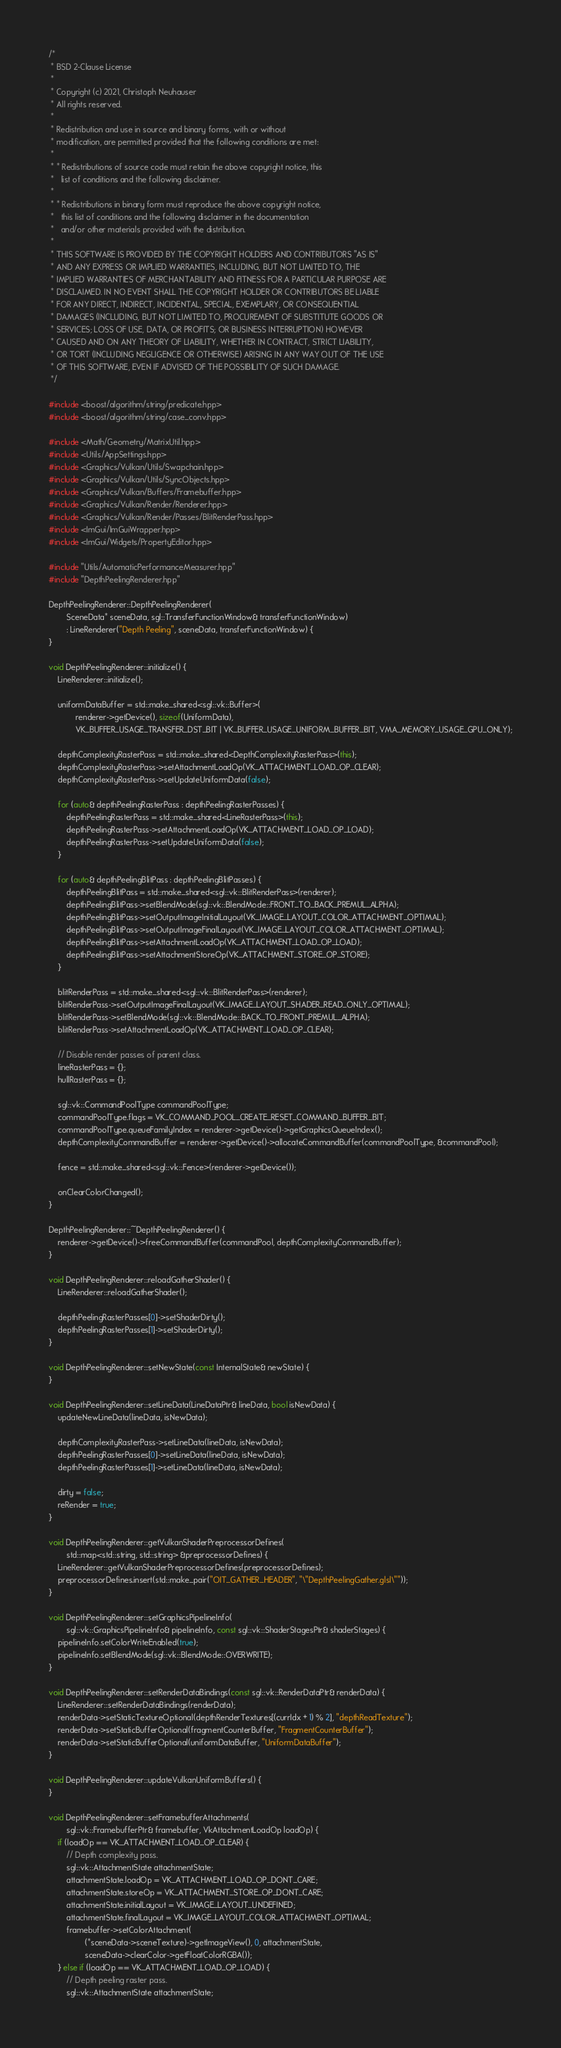<code> <loc_0><loc_0><loc_500><loc_500><_C++_>/*
 * BSD 2-Clause License
 *
 * Copyright (c) 2021, Christoph Neuhauser
 * All rights reserved.
 *
 * Redistribution and use in source and binary forms, with or without
 * modification, are permitted provided that the following conditions are met:
 *
 * * Redistributions of source code must retain the above copyright notice, this
 *   list of conditions and the following disclaimer.
 *
 * * Redistributions in binary form must reproduce the above copyright notice,
 *   this list of conditions and the following disclaimer in the documentation
 *   and/or other materials provided with the distribution.
 *
 * THIS SOFTWARE IS PROVIDED BY THE COPYRIGHT HOLDERS AND CONTRIBUTORS "AS IS"
 * AND ANY EXPRESS OR IMPLIED WARRANTIES, INCLUDING, BUT NOT LIMITED TO, THE
 * IMPLIED WARRANTIES OF MERCHANTABILITY AND FITNESS FOR A PARTICULAR PURPOSE ARE
 * DISCLAIMED. IN NO EVENT SHALL THE COPYRIGHT HOLDER OR CONTRIBUTORS BE LIABLE
 * FOR ANY DIRECT, INDIRECT, INCIDENTAL, SPECIAL, EXEMPLARY, OR CONSEQUENTIAL
 * DAMAGES (INCLUDING, BUT NOT LIMITED TO, PROCUREMENT OF SUBSTITUTE GOODS OR
 * SERVICES; LOSS OF USE, DATA, OR PROFITS; OR BUSINESS INTERRUPTION) HOWEVER
 * CAUSED AND ON ANY THEORY OF LIABILITY, WHETHER IN CONTRACT, STRICT LIABILITY,
 * OR TORT (INCLUDING NEGLIGENCE OR OTHERWISE) ARISING IN ANY WAY OUT OF THE USE
 * OF THIS SOFTWARE, EVEN IF ADVISED OF THE POSSIBILITY OF SUCH DAMAGE.
 */

#include <boost/algorithm/string/predicate.hpp>
#include <boost/algorithm/string/case_conv.hpp>

#include <Math/Geometry/MatrixUtil.hpp>
#include <Utils/AppSettings.hpp>
#include <Graphics/Vulkan/Utils/Swapchain.hpp>
#include <Graphics/Vulkan/Utils/SyncObjects.hpp>
#include <Graphics/Vulkan/Buffers/Framebuffer.hpp>
#include <Graphics/Vulkan/Render/Renderer.hpp>
#include <Graphics/Vulkan/Render/Passes/BlitRenderPass.hpp>
#include <ImGui/ImGuiWrapper.hpp>
#include <ImGui/Widgets/PropertyEditor.hpp>

#include "Utils/AutomaticPerformanceMeasurer.hpp"
#include "DepthPeelingRenderer.hpp"

DepthPeelingRenderer::DepthPeelingRenderer(
        SceneData* sceneData, sgl::TransferFunctionWindow& transferFunctionWindow)
        : LineRenderer("Depth Peeling", sceneData, transferFunctionWindow) {
}

void DepthPeelingRenderer::initialize() {
    LineRenderer::initialize();

    uniformDataBuffer = std::make_shared<sgl::vk::Buffer>(
            renderer->getDevice(), sizeof(UniformData),
            VK_BUFFER_USAGE_TRANSFER_DST_BIT | VK_BUFFER_USAGE_UNIFORM_BUFFER_BIT, VMA_MEMORY_USAGE_GPU_ONLY);

    depthComplexityRasterPass = std::make_shared<DepthComplexityRasterPass>(this);
    depthComplexityRasterPass->setAttachmentLoadOp(VK_ATTACHMENT_LOAD_OP_CLEAR);
    depthComplexityRasterPass->setUpdateUniformData(false);

    for (auto& depthPeelingRasterPass : depthPeelingRasterPasses) {
        depthPeelingRasterPass = std::make_shared<LineRasterPass>(this);
        depthPeelingRasterPass->setAttachmentLoadOp(VK_ATTACHMENT_LOAD_OP_LOAD);
        depthPeelingRasterPass->setUpdateUniformData(false);
    }

    for (auto& depthPeelingBlitPass : depthPeelingBlitPasses) {
        depthPeelingBlitPass = std::make_shared<sgl::vk::BlitRenderPass>(renderer);
        depthPeelingBlitPass->setBlendMode(sgl::vk::BlendMode::FRONT_TO_BACK_PREMUL_ALPHA);
        depthPeelingBlitPass->setOutputImageInitialLayout(VK_IMAGE_LAYOUT_COLOR_ATTACHMENT_OPTIMAL);
        depthPeelingBlitPass->setOutputImageFinalLayout(VK_IMAGE_LAYOUT_COLOR_ATTACHMENT_OPTIMAL);
        depthPeelingBlitPass->setAttachmentLoadOp(VK_ATTACHMENT_LOAD_OP_LOAD);
        depthPeelingBlitPass->setAttachmentStoreOp(VK_ATTACHMENT_STORE_OP_STORE);
    }

    blitRenderPass = std::make_shared<sgl::vk::BlitRenderPass>(renderer);
    blitRenderPass->setOutputImageFinalLayout(VK_IMAGE_LAYOUT_SHADER_READ_ONLY_OPTIMAL);
    blitRenderPass->setBlendMode(sgl::vk::BlendMode::BACK_TO_FRONT_PREMUL_ALPHA);
    blitRenderPass->setAttachmentLoadOp(VK_ATTACHMENT_LOAD_OP_CLEAR);

    // Disable render passes of parent class.
    lineRasterPass = {};
    hullRasterPass = {};

    sgl::vk::CommandPoolType commandPoolType;
    commandPoolType.flags = VK_COMMAND_POOL_CREATE_RESET_COMMAND_BUFFER_BIT;
    commandPoolType.queueFamilyIndex = renderer->getDevice()->getGraphicsQueueIndex();
    depthComplexityCommandBuffer = renderer->getDevice()->allocateCommandBuffer(commandPoolType, &commandPool);

    fence = std::make_shared<sgl::vk::Fence>(renderer->getDevice());

    onClearColorChanged();
}

DepthPeelingRenderer::~DepthPeelingRenderer() {
    renderer->getDevice()->freeCommandBuffer(commandPool, depthComplexityCommandBuffer);
}

void DepthPeelingRenderer::reloadGatherShader() {
    LineRenderer::reloadGatherShader();

    depthPeelingRasterPasses[0]->setShaderDirty();
    depthPeelingRasterPasses[1]->setShaderDirty();
}

void DepthPeelingRenderer::setNewState(const InternalState& newState) {
}

void DepthPeelingRenderer::setLineData(LineDataPtr& lineData, bool isNewData) {
    updateNewLineData(lineData, isNewData);

    depthComplexityRasterPass->setLineData(lineData, isNewData);
    depthPeelingRasterPasses[0]->setLineData(lineData, isNewData);
    depthPeelingRasterPasses[1]->setLineData(lineData, isNewData);

    dirty = false;
    reRender = true;
}

void DepthPeelingRenderer::getVulkanShaderPreprocessorDefines(
        std::map<std::string, std::string> &preprocessorDefines) {
    LineRenderer::getVulkanShaderPreprocessorDefines(preprocessorDefines);
    preprocessorDefines.insert(std::make_pair("OIT_GATHER_HEADER", "\"DepthPeelingGather.glsl\""));
}

void DepthPeelingRenderer::setGraphicsPipelineInfo(
        sgl::vk::GraphicsPipelineInfo& pipelineInfo, const sgl::vk::ShaderStagesPtr& shaderStages) {
    pipelineInfo.setColorWriteEnabled(true);
    pipelineInfo.setBlendMode(sgl::vk::BlendMode::OVERWRITE);
}

void DepthPeelingRenderer::setRenderDataBindings(const sgl::vk::RenderDataPtr& renderData) {
    LineRenderer::setRenderDataBindings(renderData);
    renderData->setStaticTextureOptional(depthRenderTextures[(currIdx + 1) % 2], "depthReadTexture");
    renderData->setStaticBufferOptional(fragmentCounterBuffer, "FragmentCounterBuffer");
    renderData->setStaticBufferOptional(uniformDataBuffer, "UniformDataBuffer");
}

void DepthPeelingRenderer::updateVulkanUniformBuffers() {
}

void DepthPeelingRenderer::setFramebufferAttachments(
        sgl::vk::FramebufferPtr& framebuffer, VkAttachmentLoadOp loadOp) {
    if (loadOp == VK_ATTACHMENT_LOAD_OP_CLEAR) {
        // Depth complexity pass.
        sgl::vk::AttachmentState attachmentState;
        attachmentState.loadOp = VK_ATTACHMENT_LOAD_OP_DONT_CARE;
        attachmentState.storeOp = VK_ATTACHMENT_STORE_OP_DONT_CARE;
        attachmentState.initialLayout = VK_IMAGE_LAYOUT_UNDEFINED;
        attachmentState.finalLayout = VK_IMAGE_LAYOUT_COLOR_ATTACHMENT_OPTIMAL;
        framebuffer->setColorAttachment(
                (*sceneData->sceneTexture)->getImageView(), 0, attachmentState,
                sceneData->clearColor->getFloatColorRGBA());
    } else if (loadOp == VK_ATTACHMENT_LOAD_OP_LOAD) {
        // Depth peeling raster pass.
        sgl::vk::AttachmentState attachmentState;</code> 